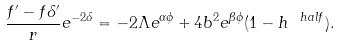<formula> <loc_0><loc_0><loc_500><loc_500>\frac { f ^ { \prime } - f \delta ^ { \prime } } { r } e ^ { - 2 \delta } = - 2 \Lambda e ^ { \alpha \phi } + 4 b ^ { 2 } e ^ { \beta \phi } ( 1 - h ^ { \ h a l f } ) .</formula> 